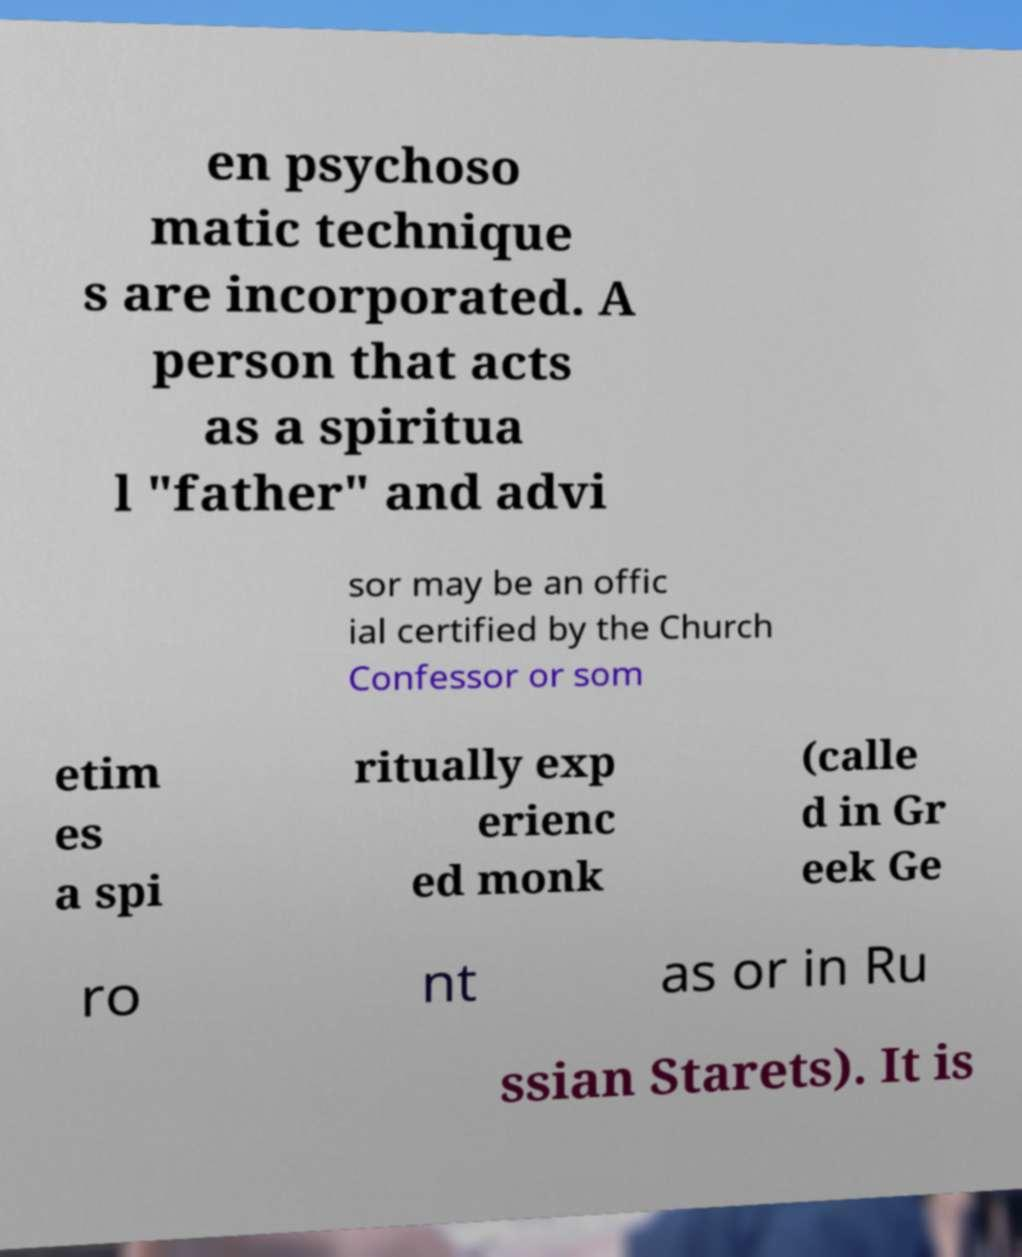What messages or text are displayed in this image? I need them in a readable, typed format. en psychoso matic technique s are incorporated. A person that acts as a spiritua l "father" and advi sor may be an offic ial certified by the Church Confessor or som etim es a spi ritually exp erienc ed monk (calle d in Gr eek Ge ro nt as or in Ru ssian Starets). It is 